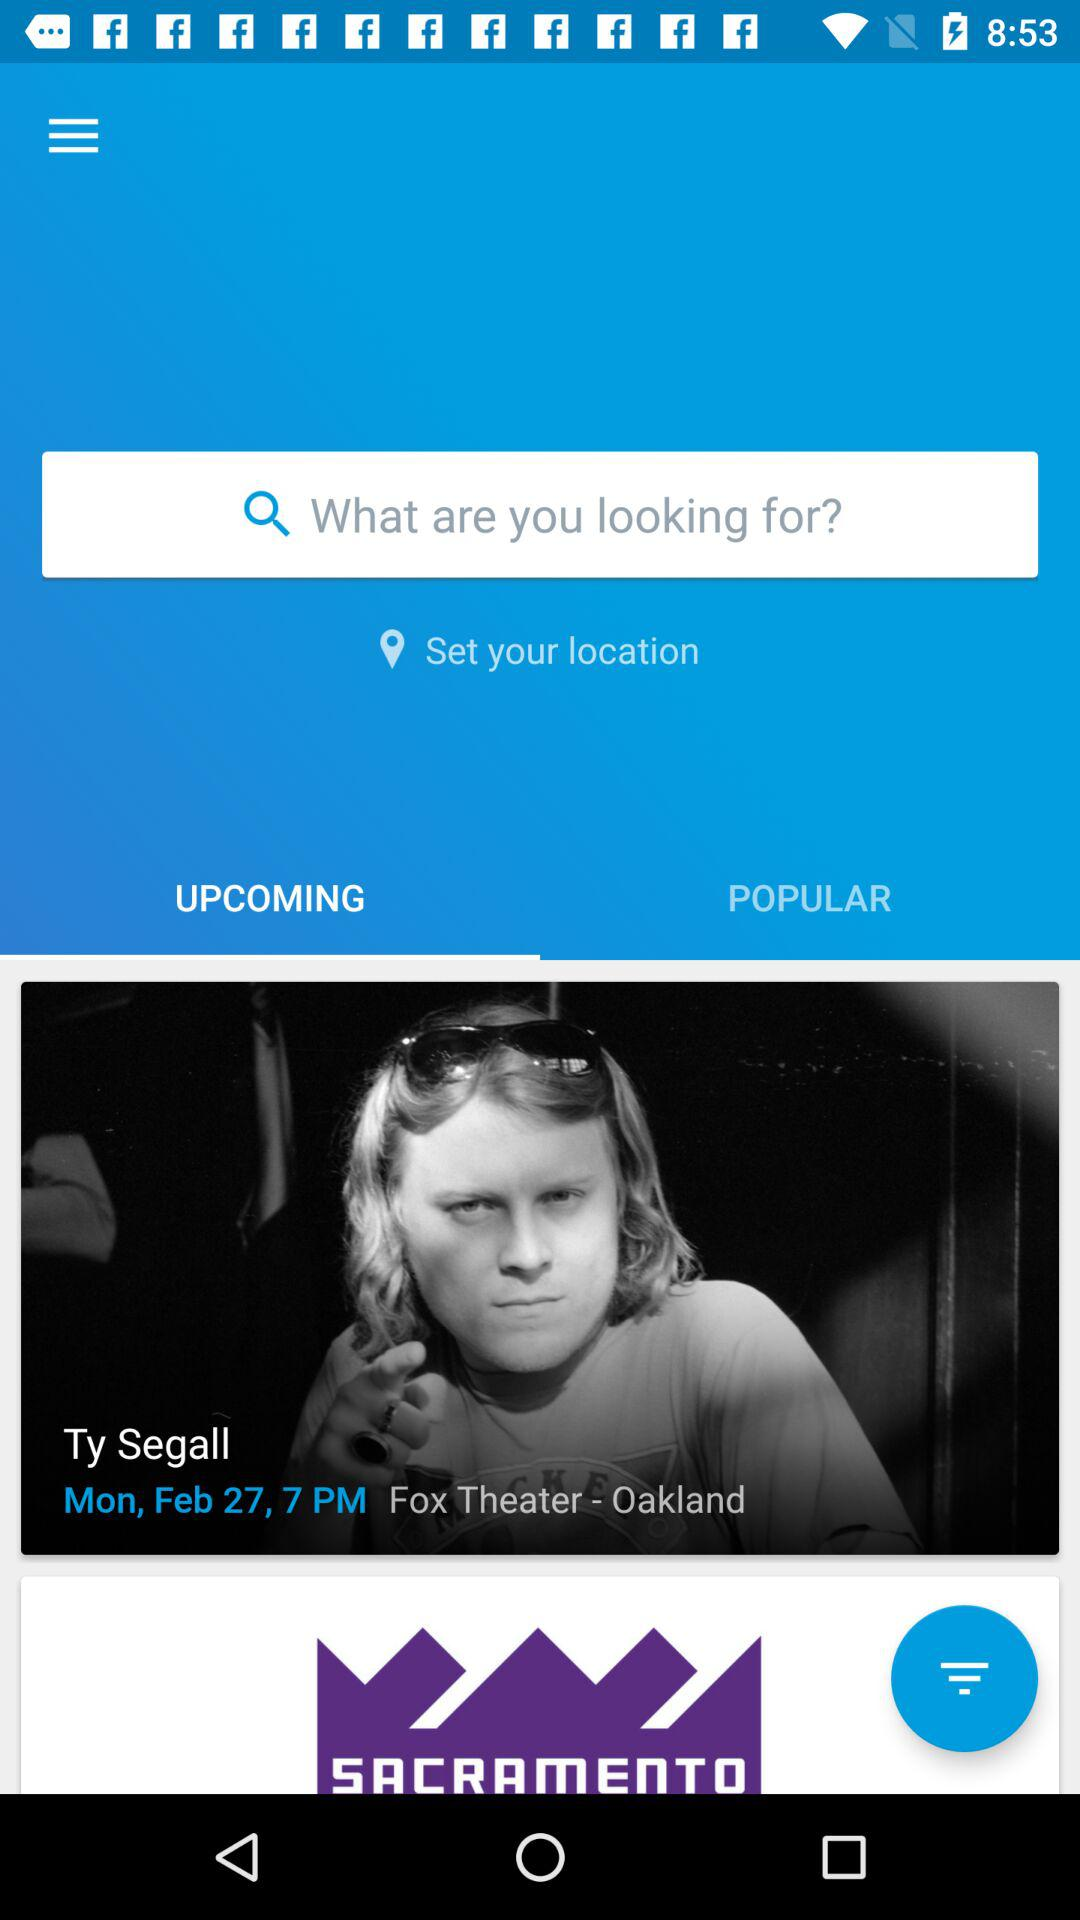What option is selected? The selected option is "UPCOMING". 